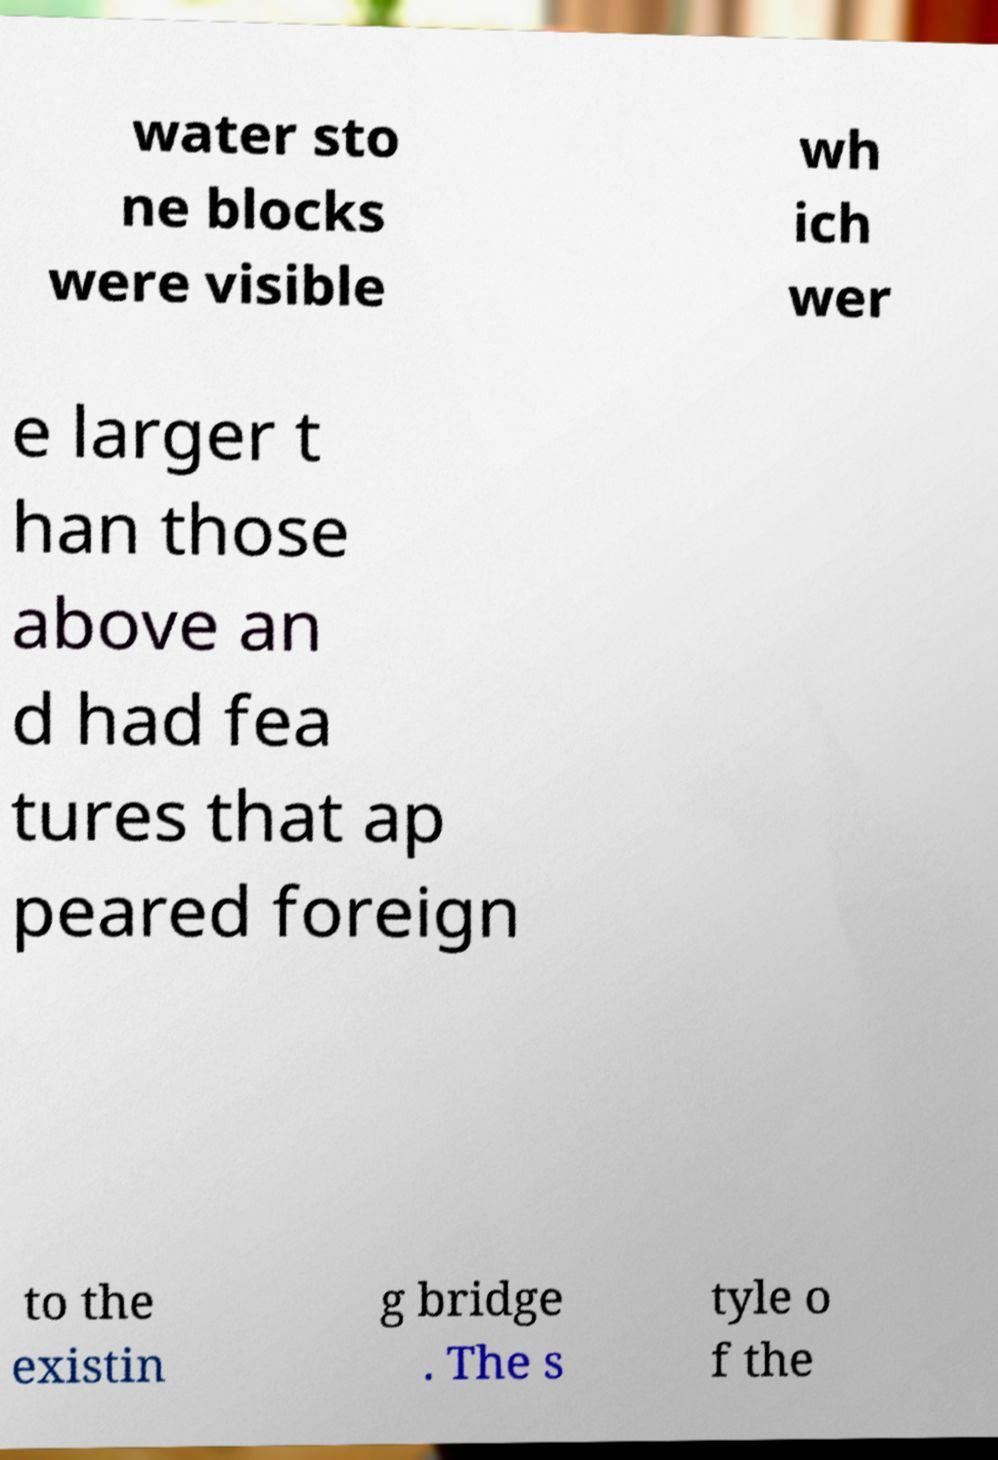What messages or text are displayed in this image? I need them in a readable, typed format. water sto ne blocks were visible wh ich wer e larger t han those above an d had fea tures that ap peared foreign to the existin g bridge . The s tyle o f the 